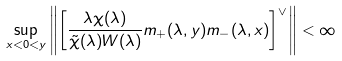<formula> <loc_0><loc_0><loc_500><loc_500>\sup _ { x < 0 < y } \left \| \left [ \frac { \lambda \chi ( \lambda ) } { \tilde { \chi } ( \lambda ) W ( \lambda ) } m _ { + } ( \lambda , y ) m _ { - } ( \lambda , x ) \right ] ^ { \vee } \right \| < \infty</formula> 